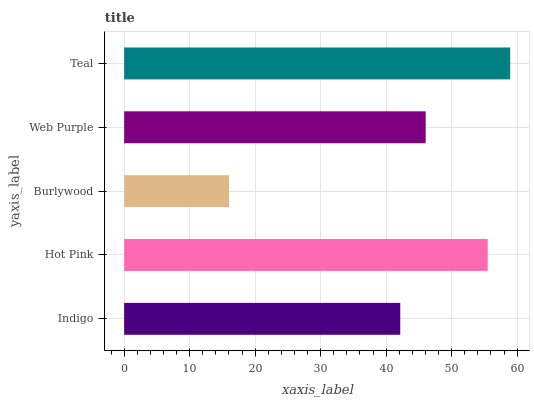Is Burlywood the minimum?
Answer yes or no. Yes. Is Teal the maximum?
Answer yes or no. Yes. Is Hot Pink the minimum?
Answer yes or no. No. Is Hot Pink the maximum?
Answer yes or no. No. Is Hot Pink greater than Indigo?
Answer yes or no. Yes. Is Indigo less than Hot Pink?
Answer yes or no. Yes. Is Indigo greater than Hot Pink?
Answer yes or no. No. Is Hot Pink less than Indigo?
Answer yes or no. No. Is Web Purple the high median?
Answer yes or no. Yes. Is Web Purple the low median?
Answer yes or no. Yes. Is Teal the high median?
Answer yes or no. No. Is Burlywood the low median?
Answer yes or no. No. 